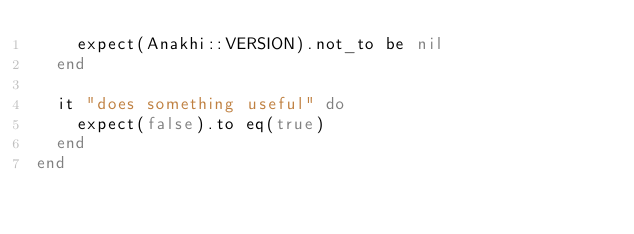<code> <loc_0><loc_0><loc_500><loc_500><_Ruby_>    expect(Anakhi::VERSION).not_to be nil
  end

  it "does something useful" do
    expect(false).to eq(true)
  end
end
</code> 